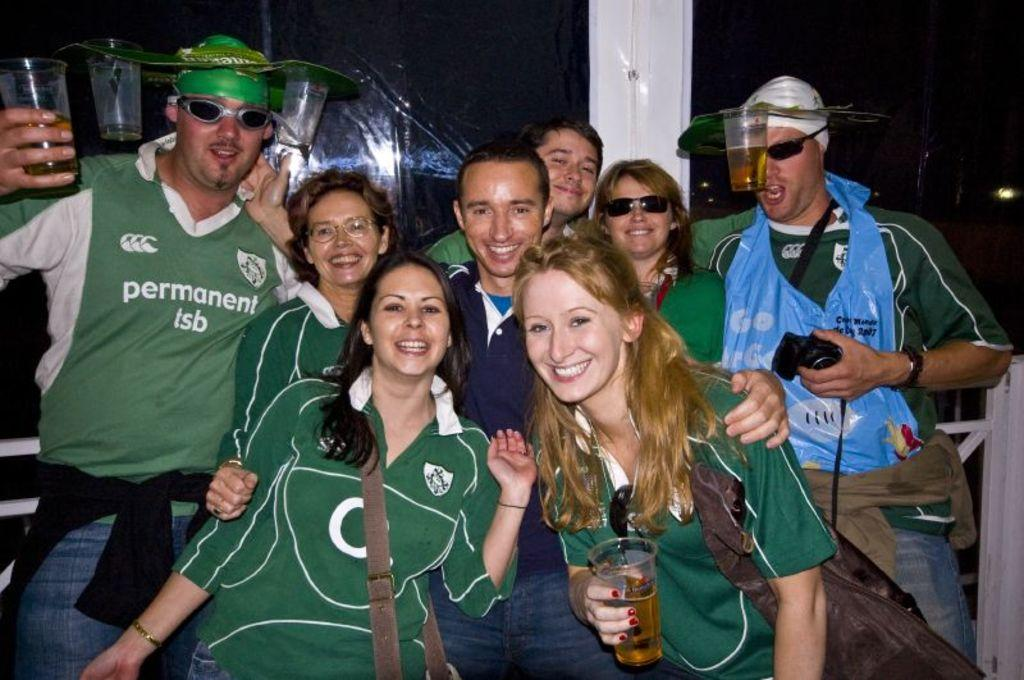What is happening in the image involving a group of people? There is a group of people in the image, and they are smiling and giving stills. Can you describe the actions of the people in the image? Two persons are holding a glass, and a man is holding a camera. What is the overall mood of the people in the image? The people in the image are smiling, which suggests a positive or happy mood. What type of stocking is visible on the man holding the camera in the image? There is no stocking visible on the man holding the camera in the image. What kind of net is being used by the people in the image? There is no net present in the image; the people are holding a glass and a camera. 